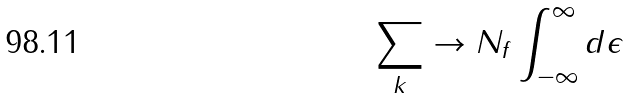<formula> <loc_0><loc_0><loc_500><loc_500>\sum _ { k } \rightarrow N _ { f } \int _ { - \infty } ^ { \infty } d \epsilon</formula> 